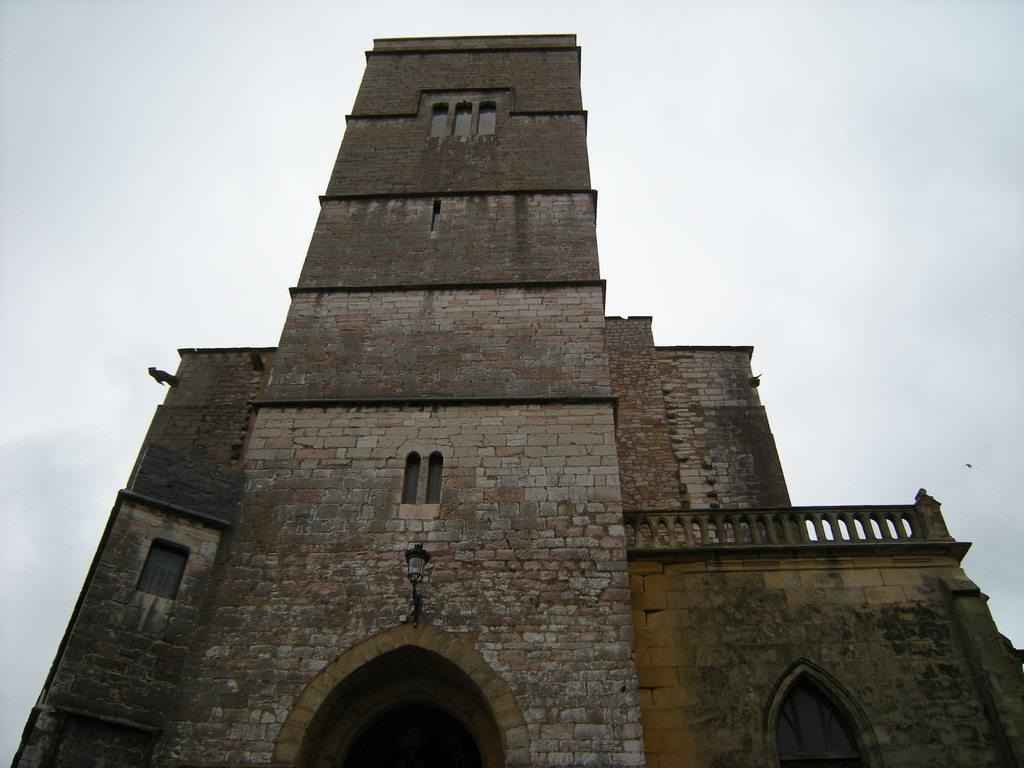What type of structure is present in the image? There is a building in the image. What can be seen at the top of the image? The sky is visible at the top of the image. How many chairs are floating in the sea in the image? There is no sea or chairs present in the image; it only features a building and the sky. 